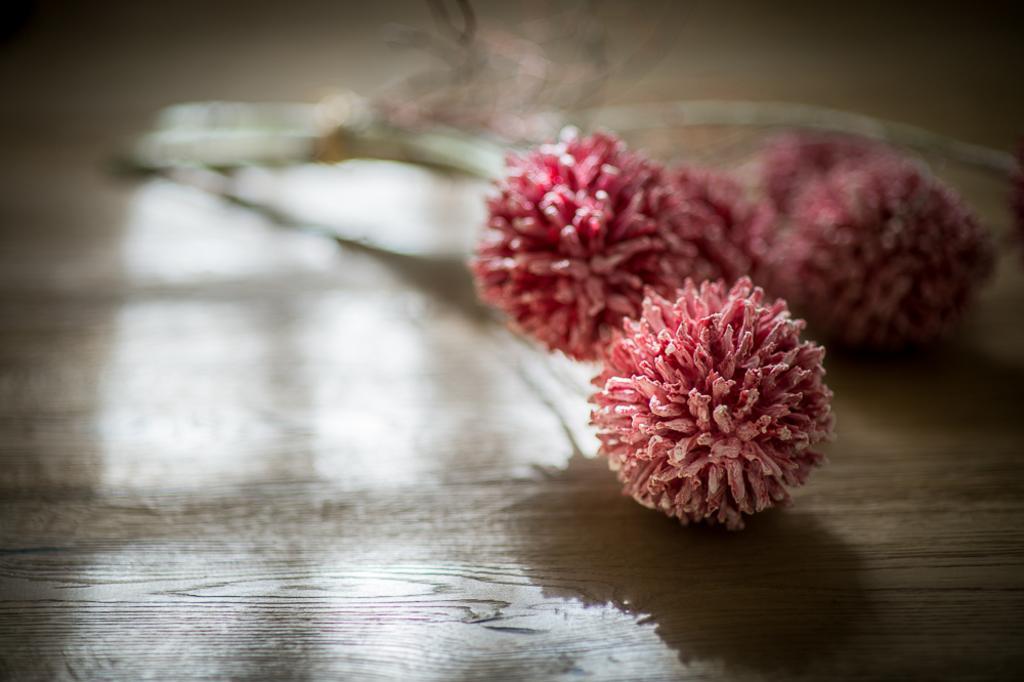Please provide a concise description of this image. In this image I can see the flowers on the floor. 